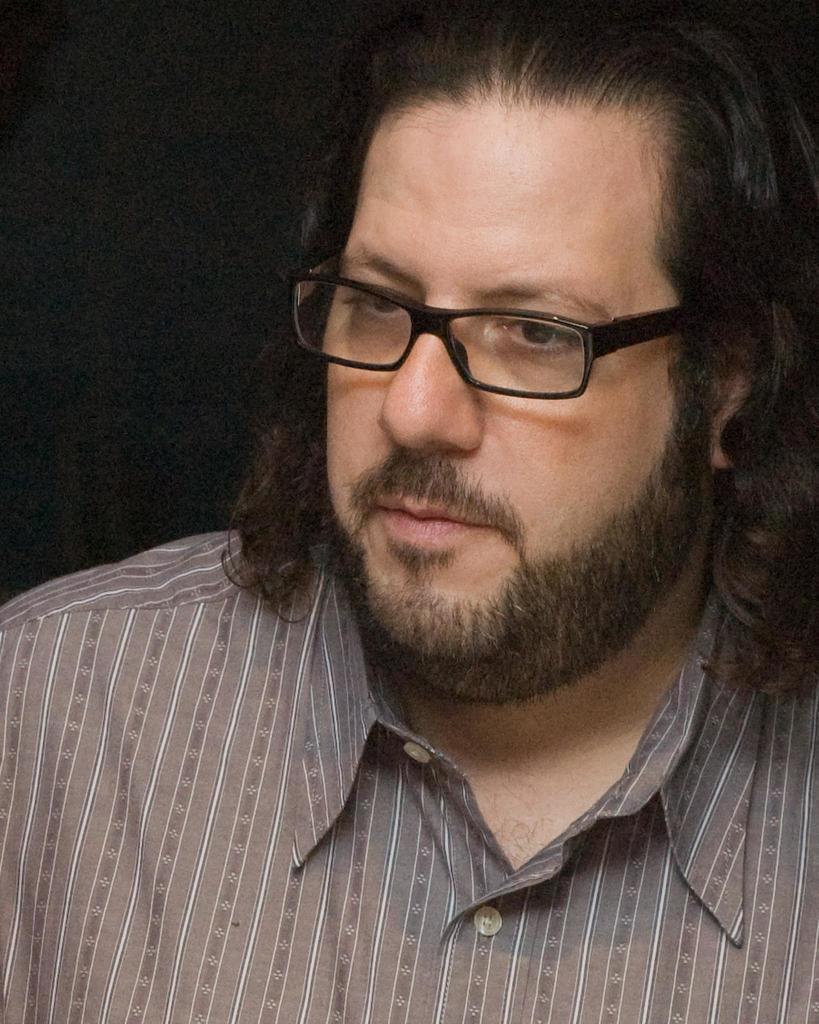Describe this image in one or two sentences. In this picture I can see a man with spectacles, and there is dark background. 